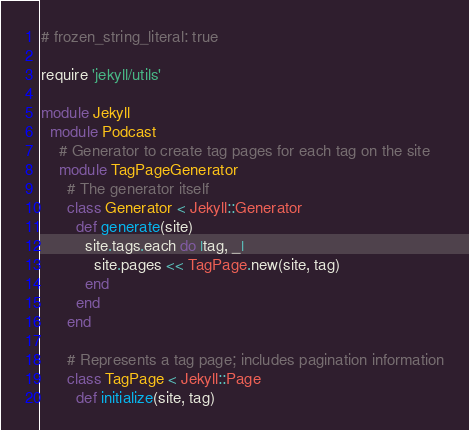Convert code to text. <code><loc_0><loc_0><loc_500><loc_500><_Ruby_># frozen_string_literal: true

require 'jekyll/utils'

module Jekyll
  module Podcast
    # Generator to create tag pages for each tag on the site
    module TagPageGenerator
      # The generator itself
      class Generator < Jekyll::Generator
        def generate(site)
          site.tags.each do |tag, _|
            site.pages << TagPage.new(site, tag)
          end
        end
      end

      # Represents a tag page; includes pagination information
      class TagPage < Jekyll::Page
        def initialize(site, tag)</code> 